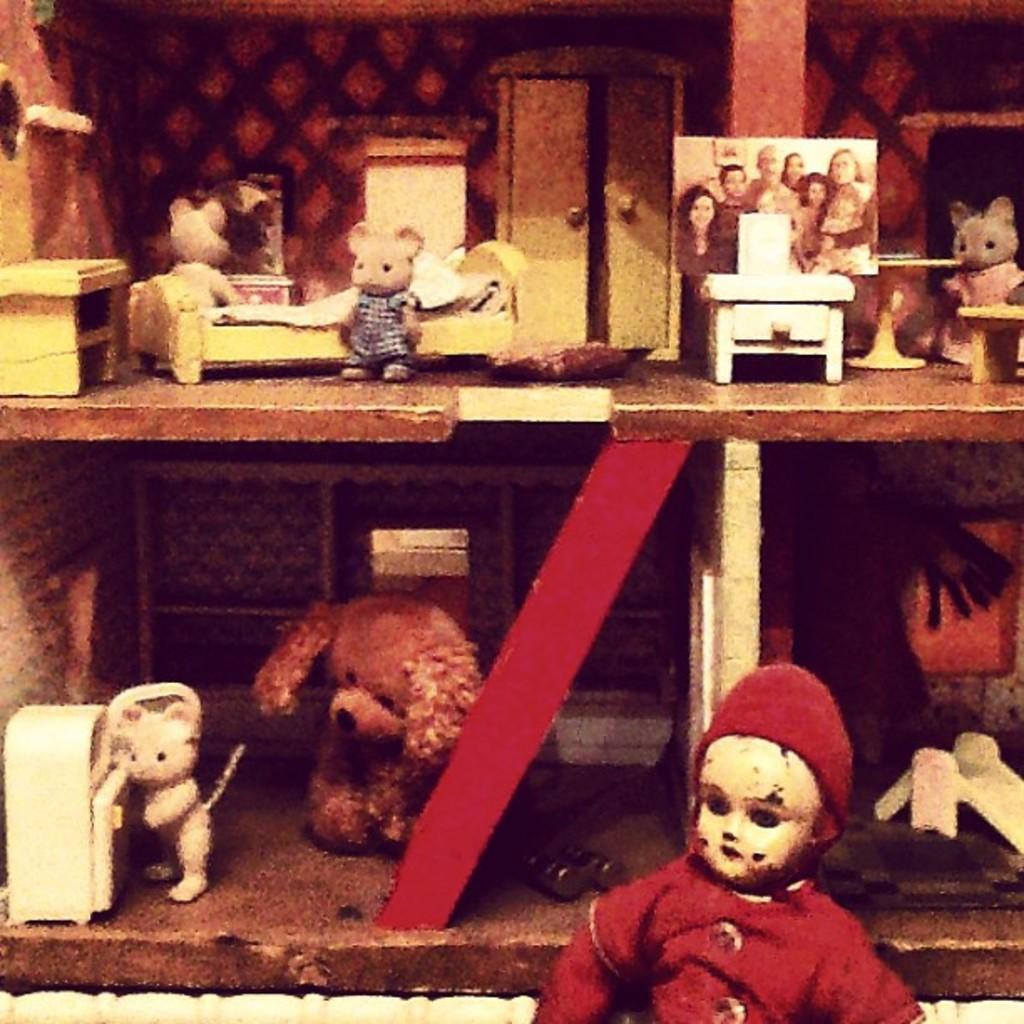In one or two sentences, can you explain what this image depicts? In this image I see the shelves on which there are soft toys and I see a doll over here and I can also see a picture in which there are few persons and I see few more things over here. 